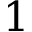<formula> <loc_0><loc_0><loc_500><loc_500>1</formula> 